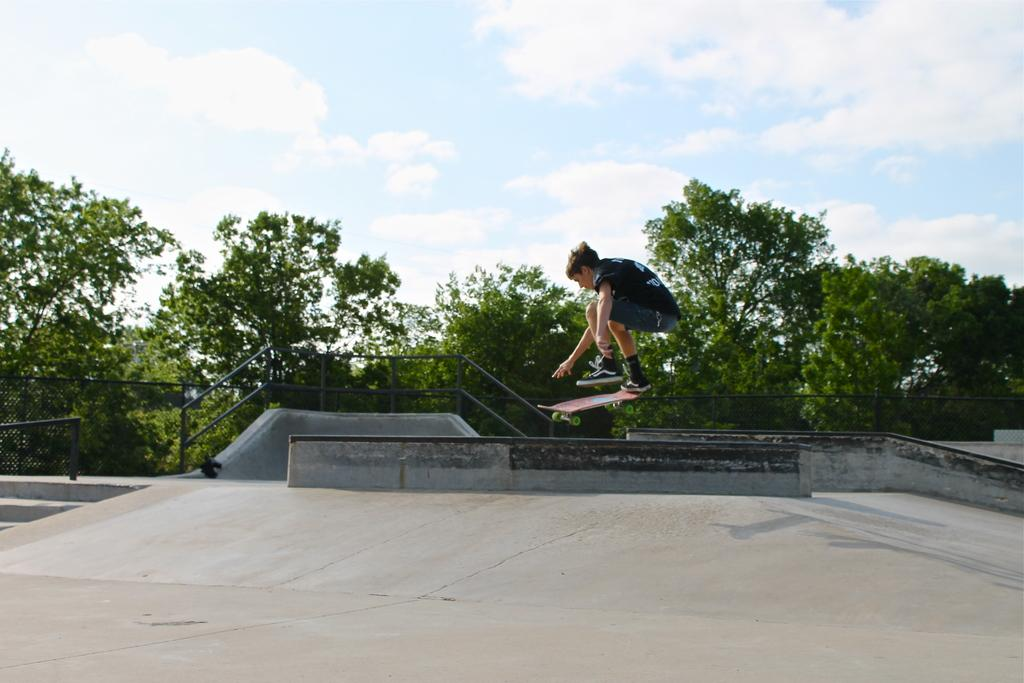What is the main subject of the image? There is a person in the image. What is the person doing in the image? The person is on a skateboard. What is the position of the skateboard in the image? The skateboard is in the air. What is the surface beneath the person and skateboard? There is a floor in the image. What can be seen in the background of the image? There is a fence, poles, trees, and clouds in the sky in the background of the image. What color is the crayon being used by the person on the skateboard in the image? There is no crayon present in the image; the person is on a skateboard. How does the person on the skateboard plan to reach the land in the image? The image does not depict any land, and the person is already on a skateboard, so there is no need to reach land. 